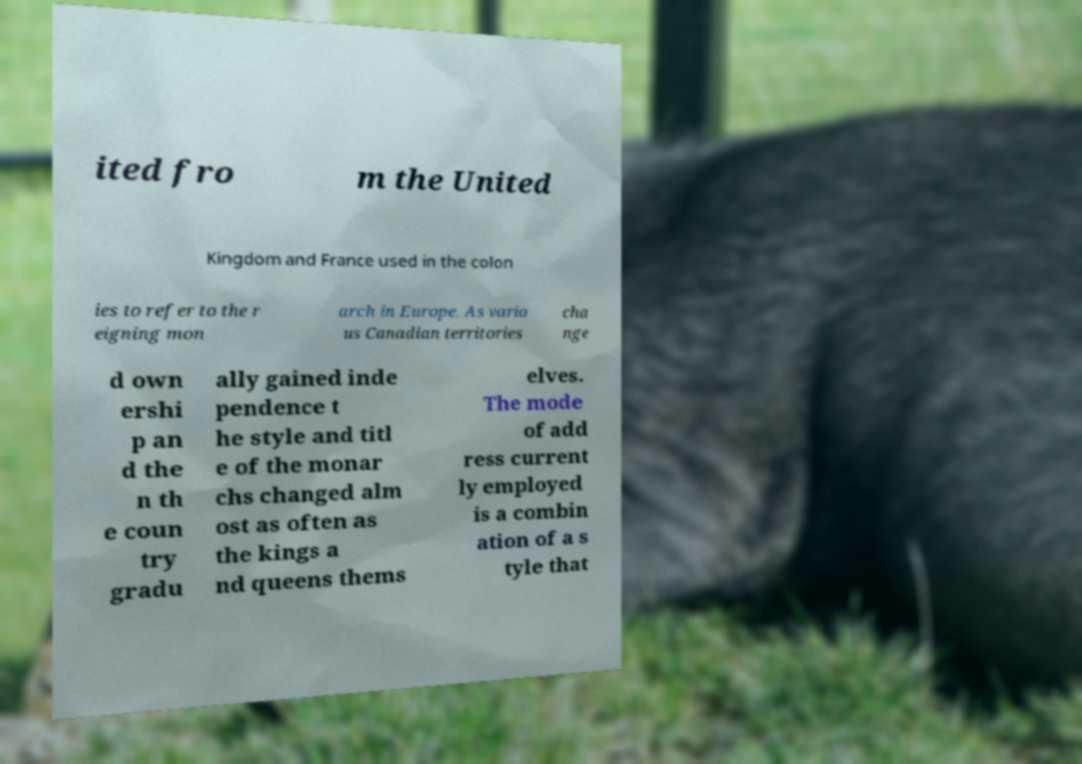Can you read and provide the text displayed in the image?This photo seems to have some interesting text. Can you extract and type it out for me? ited fro m the United Kingdom and France used in the colon ies to refer to the r eigning mon arch in Europe. As vario us Canadian territories cha nge d own ershi p an d the n th e coun try gradu ally gained inde pendence t he style and titl e of the monar chs changed alm ost as often as the kings a nd queens thems elves. The mode of add ress current ly employed is a combin ation of a s tyle that 